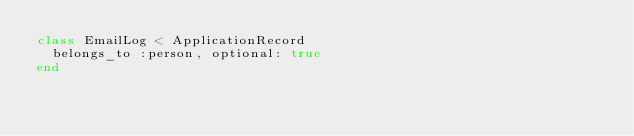Convert code to text. <code><loc_0><loc_0><loc_500><loc_500><_Ruby_>class EmailLog < ApplicationRecord
  belongs_to :person, optional: true
end
</code> 